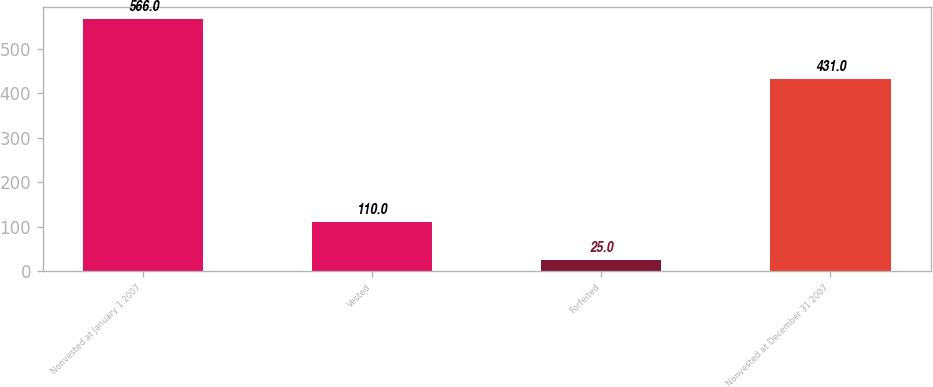<chart> <loc_0><loc_0><loc_500><loc_500><bar_chart><fcel>Nonvested at January 1 2007<fcel>Vested<fcel>Forfeited<fcel>Nonvested at December 31 2007<nl><fcel>566<fcel>110<fcel>25<fcel>431<nl></chart> 